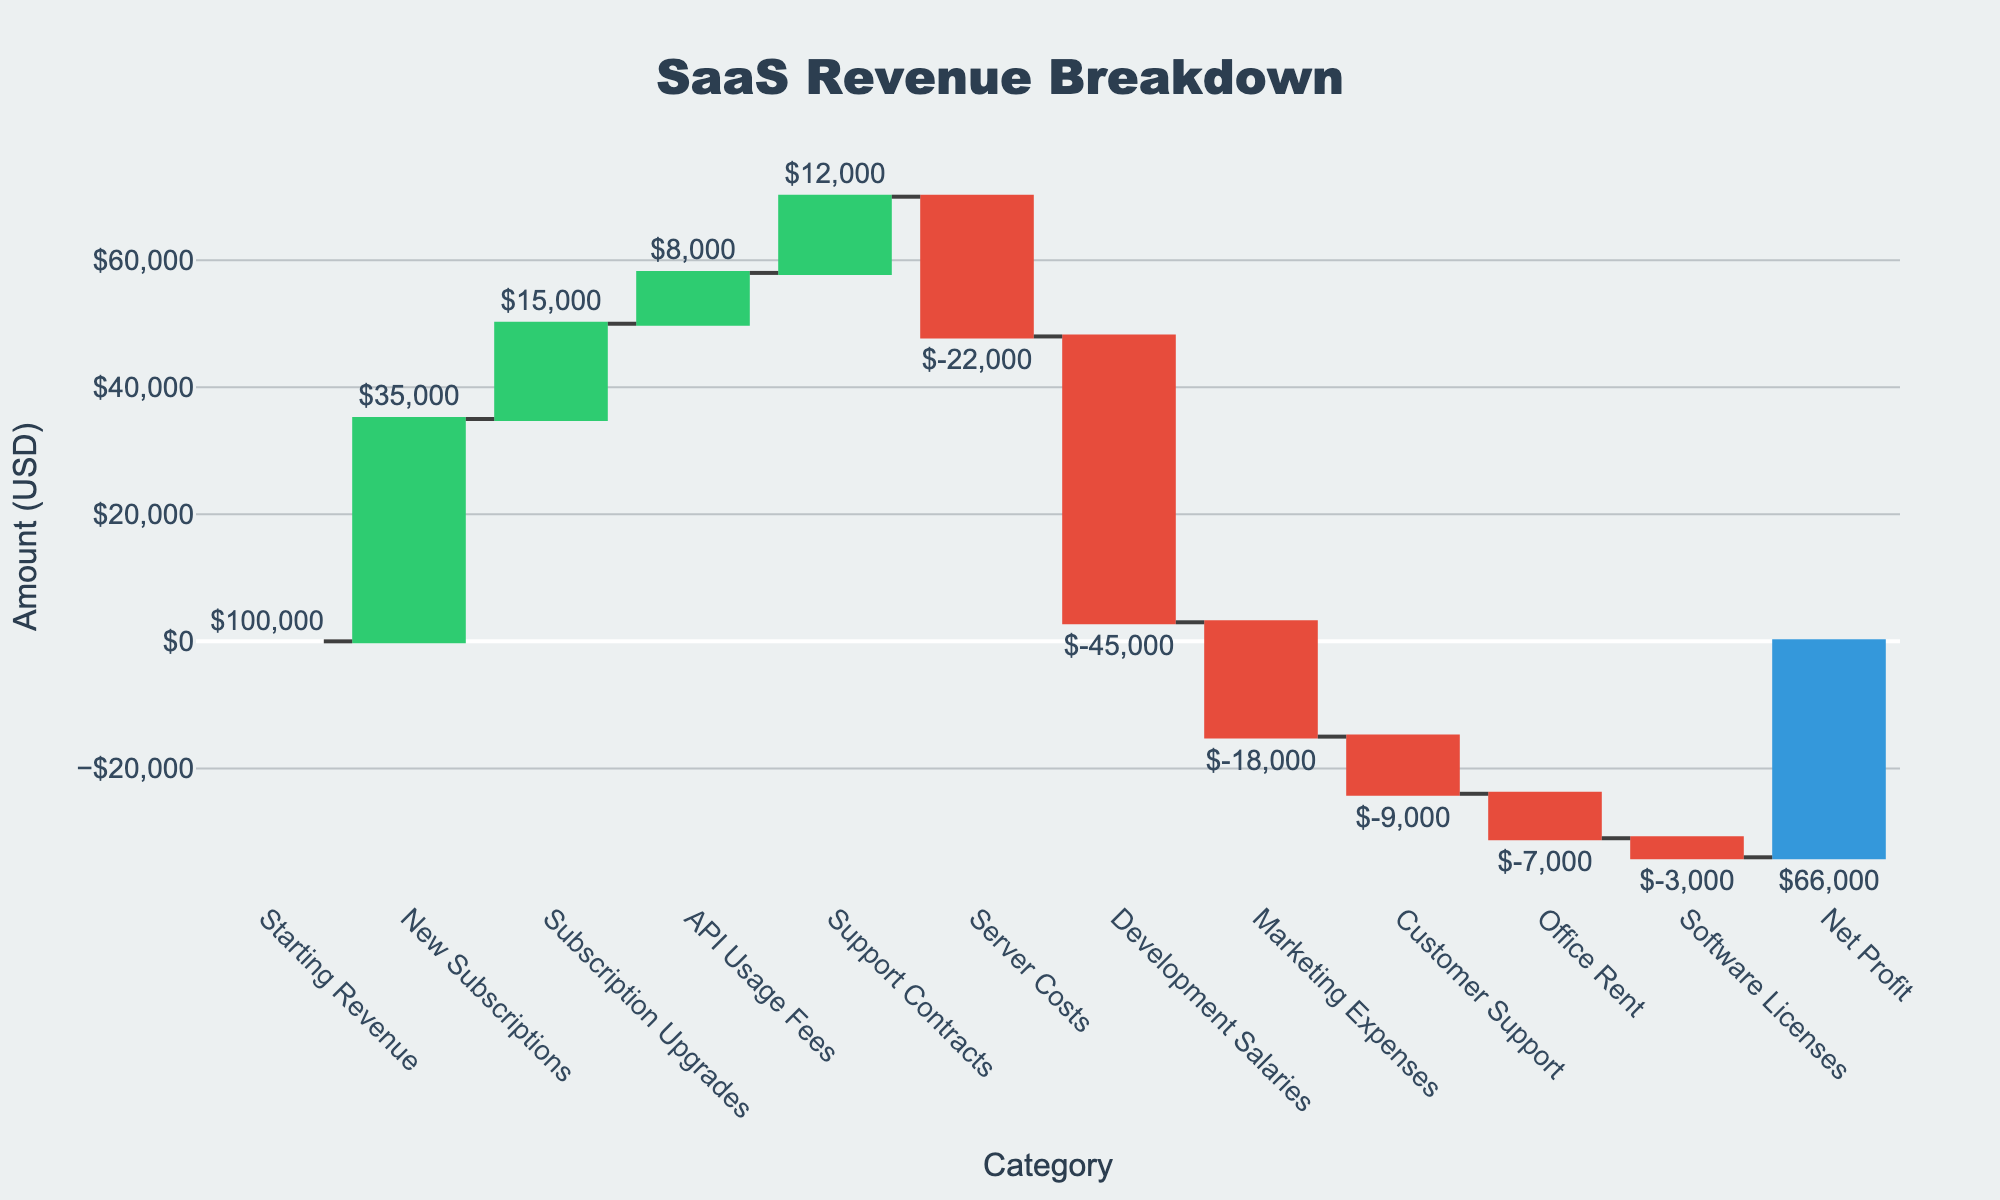What is the title of the chart? The title of the chart appears at the top and is labeled "SaaS Revenue Breakdown".
Answer: SaaS Revenue Breakdown How many categories of income and expenses are displayed in the chart? The x-axis labels show the categories represented in the waterfall chart. Counting them gives us a total of 12 categories.
Answer: 12 What is the starting revenue in the chart? The first bar, labeled "Starting Revenue," displays the starting revenue, which is $100,000.
Answer: $100,000 What is the net profit for the SaaS product? The last bar, labeled "Net Profit," shows the net profit, which is $66,000.
Answer: $66,000 How much did new subscriptions contribute to the revenue? The bar corresponding to "New Subscriptions" shows a contribution of $35,000 to the revenue.
Answer: $35,000 How much were the server costs, and what color represents them in the chart? The bar labeled "Server Costs" has a value of -$22,000, and it is represented in red, indicating an expense.
Answer: -$22,000 and red Which income category contributed the least to the revenue, and how much was it? By examining the height of the bars that represent income, "API Usage Fees" contributes the least with $8,000.
Answer: API Usage Fees, $8,000 What is the total amount spent on marketing and customer support? Add the amounts for "Marketing Expenses" and "Customer Support": $18,000 + $9,000 = $27,000.
Answer: $27,000 Which expense category is the largest, and how does its amount compare to development salaries? The largest expense category is "Development Salaries" at -$45,000.
Answer: Development Salaries, -$45,000 What is the difference between total income (excluding Starting Revenue) and total expenses? Calculate the total of income categories: $35,000 (New Subscriptions) + $15,000 (Subscription Upgrades) + $8,000 (API Usage Fees) + $12,000 (Support Contracts) = $70,000. Calculate the total of expense categories: -$22,000 (Server Costs) - $45,000 (Development Salaries) - $18,000 (Marketing Expenses) - $9,000 (Customer Support) - $7,000 (Office Rent) - $3,000 (Software Licenses) = -$104,000. The difference is $70,000 - $104,000 = -$34,000.
Answer: -$34,000 